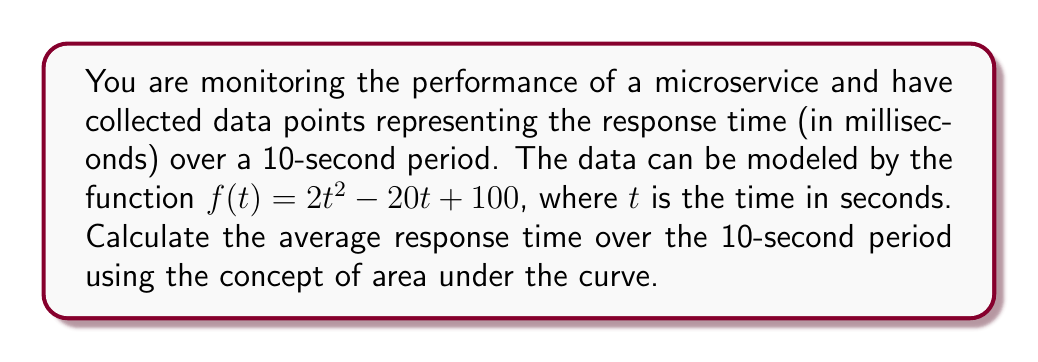Teach me how to tackle this problem. To solve this problem, we need to follow these steps:

1. Calculate the area under the curve of $f(t)$ from $t=0$ to $t=10$.
2. Divide the result by the time period (10 seconds) to get the average.

Step 1: Calculate the area under the curve

The area under the curve is given by the definite integral of $f(t)$ from 0 to 10:

$$A = \int_0^{10} (2t^2 - 20t + 100) dt$$

To solve this integral, we use the power rule of integration:

$$A = \left[\frac{2t^3}{3} - 10t^2 + 100t\right]_0^{10}$$

Now, we evaluate the expression at the upper and lower bounds:

$$A = \left(\frac{2(10^3)}{3} - 10(10^2) + 100(10)\right) - \left(\frac{2(0^3)}{3} - 10(0^2) + 100(0)\right)$$

$$A = \left(\frac{2000}{3} - 1000 + 1000\right) - 0$$

$$A = \frac{2000}{3} = 666.67$$

Step 2: Calculate the average

The average response time is the area divided by the time period:

$$\text{Average} = \frac{A}{10} = \frac{666.67}{10} = 66.67$$

Therefore, the average response time over the 10-second period is approximately 66.67 milliseconds.
Answer: 66.67 ms 